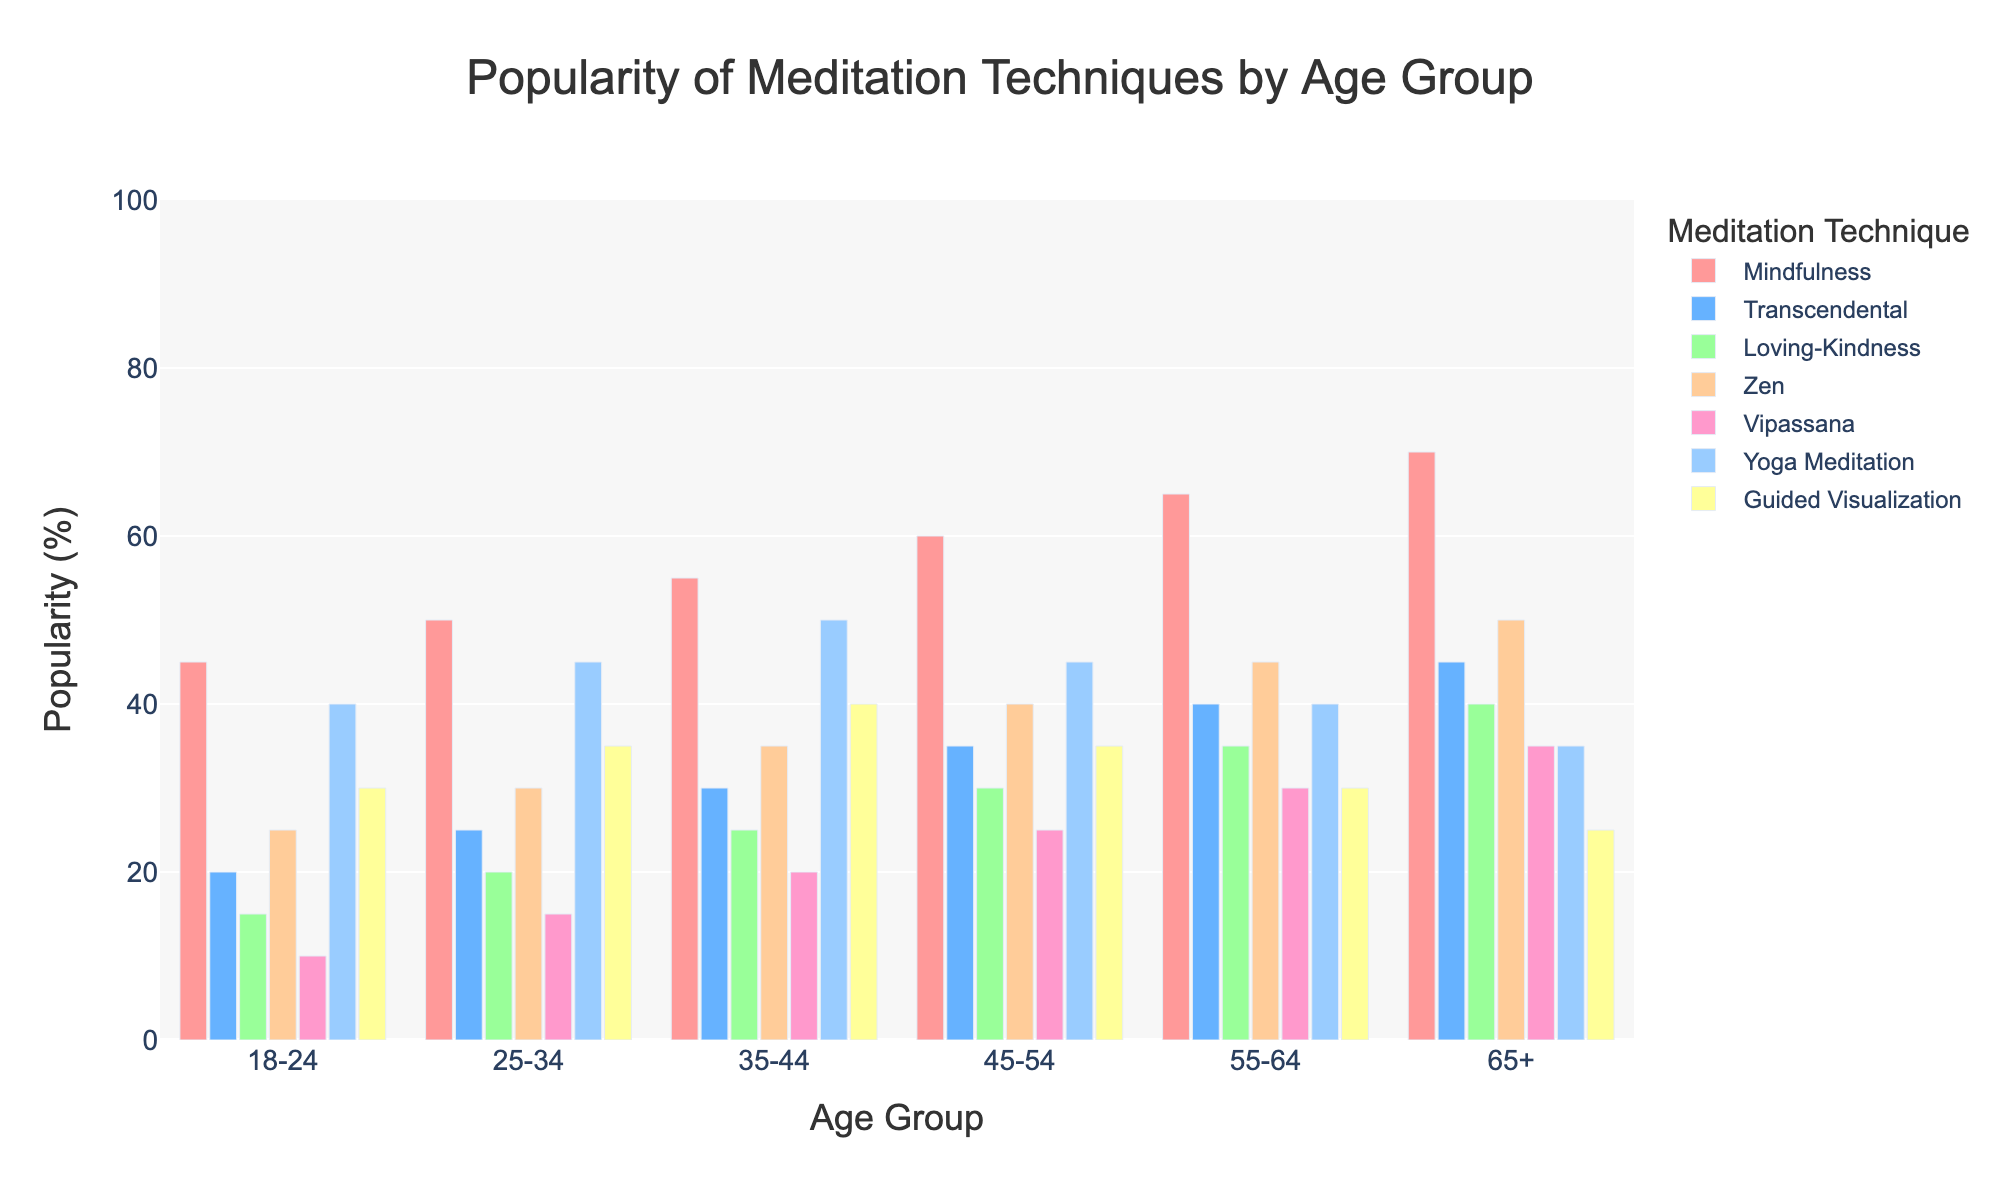What is the most popular meditation technique for the age group 18-24? The tallest bar in the age group 18-24 corresponds to Mindfulness with a height of 45%.
Answer: Mindfulness Which age group shows the highest popularity for Zen meditation? The bar for Zen meditation is highest in the age group 65+ with a value of 50%.
Answer: 65+ How does the popularity of Yoga Meditation change across the age groups? The heights of the bars for Yoga Meditation across the age groups are: 18-24 (40%), 25-34 (45%), 35-44 (50%), 45-54 (45%), 55-64 (40%), and 65+ (35%). The popularity peaks at 35-44 and then decreases.
Answer: Peaks at 35-44 and decreases What is the average popularity of Transcendental meditation across all age groups? Sum the values of Transcendental meditation for all age groups: (20 + 25 + 30 + 35 + 40 + 45) = 195. Divide by the number of age groups (6). 195 / 6 = 32.5%.
Answer: 32.5% Which technique has the least growth in popularity from age group 18-24 to 65+? Calculate the difference in popularity for each technique between age group 18-24 and 65+: Mindfulness (70-45 = 25), Transcendental (45-20 = 25), Loving-Kindness (40-15 = 25), Zen (50-25 = 25), Vipassana (35-10 = 25), Yoga Meditation (35-40 = -5), Guided Visualization (30-30 = -5). Yoga Meditation and Guided Visualization both show no growth.
Answer: Yoga Meditation and Guided Visualization Which technique shows the most significant increase in popularity from age group 18-24 to 65+? Calculate the difference in popularity for each technique between age group 18-24 and 65+: Mindfulness (70-45 = 25), Transcendental (45-20 = 25), Loving-Kindness (40-15 = 25), Zen (50-25 = 25), Vipassana (35-10 = 25), Yoga Meditation (35-40 = -5), Guided Visualization (30-30 = -5). All positive gains are 25%.
Answer: Equal increase across multiple techniques Compare the popularity of Guided Visualization and Loving-Kindness meditation in the age group 35-44. The bar heights for Guided Visualization and Loving-Kindness in the age group 35-44 are 40% and 25%, respectively. Guided Visualization is more popular.
Answer: Guided Visualization What is the popularity range (difference between maximum and minimum) of Mindfulness across all age groups? Calculate the popularity range: maximum (70%) - minimum (45%). Range = 70 - 45 = 25%.
Answer: 25% Among the age group 55-64, which technique is equally popular? The technique with equal bar heights in the age group 55-64 are Vipassana and Yoga Meditation, both at 40%.
Answer: Vipassana and Yoga Meditation Which age group has the lowest average popularity across all meditation techniques? Calculate the average popularity for each age group and find the lowest. For age group 18-24: (45+20+15+25+10+40+30)/7 = 26.4%, for 25-34: (50+25+20+30+15+45+35)/7 = 31.4%, for 35-44: (55+30+25+35+20+50+40)/7 = 36.4%, for 45-54: (60+35+30+40+25+45+35)/7 = 38.6%, for 55-64: (65+40+35+45+30+40+30)/7 = 40.7%, for 65+: (70+45+40+50+35+35+25)/7 = 42.9%. Age group 18-24 has the lowest average popularity.
Answer: 18-24 